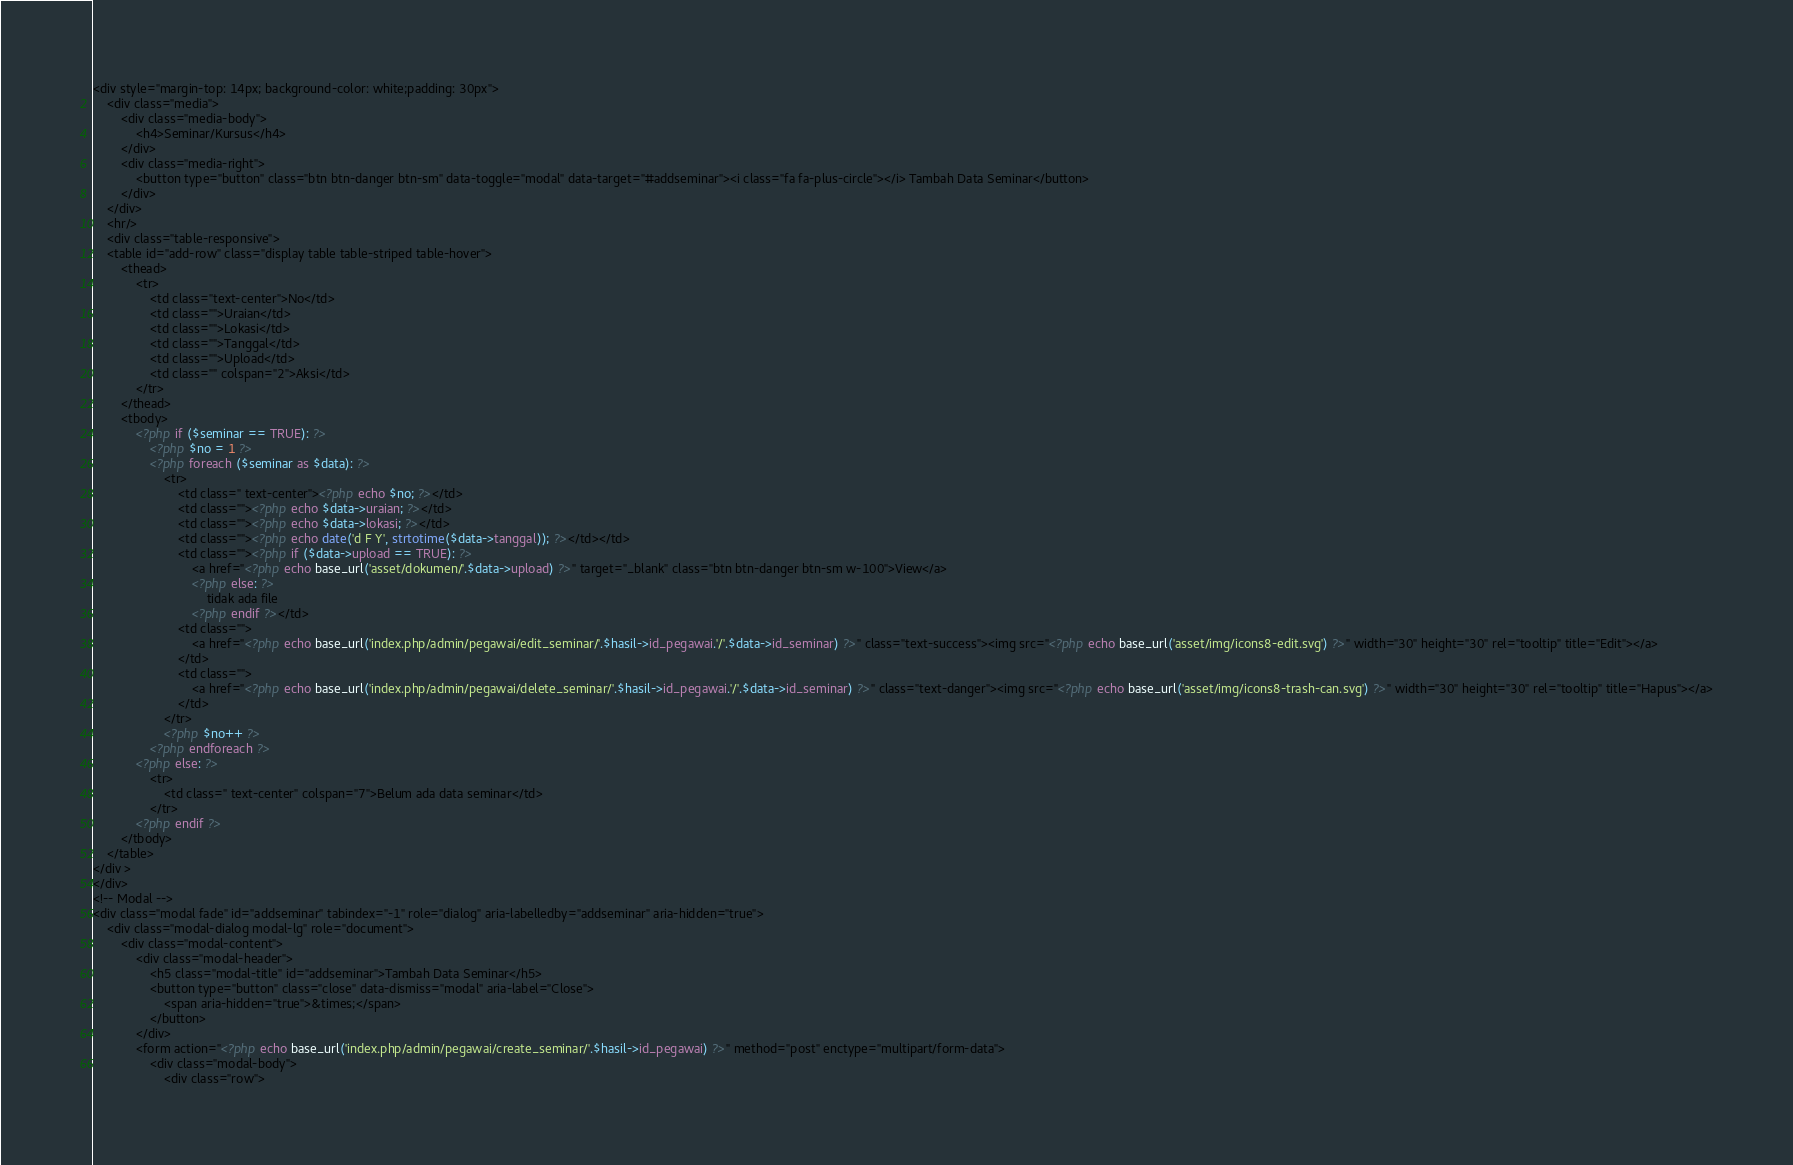<code> <loc_0><loc_0><loc_500><loc_500><_PHP_><div style="margin-top: 14px; background-color: white;padding: 30px">
	<div class="media">
		<div class="media-body">
			<h4>Seminar/Kursus</h4>
		</div>
		<div class="media-right">
			<button type="button" class="btn btn-danger btn-sm" data-toggle="modal" data-target="#addseminar"><i class="fa fa-plus-circle"></i> Tambah Data Seminar</button>
		</div>
	</div>
	<hr/>
	<div class="table-responsive">
	<table id="add-row" class="display table table-striped table-hover">
		<thead>
			<tr>
				<td class="text-center">No</td>
				<td class="">Uraian</td>
				<td class="">Lokasi</td>
				<td class="">Tanggal</td>
				<td class="">Upload</td>
				<td class="" colspan="2">Aksi</td>
			</tr>
		</thead>
		<tbody>
			<?php if ($seminar == TRUE): ?>
				<?php $no = 1 ?>
				<?php foreach ($seminar as $data): ?>
					<tr>
						<td class=" text-center"><?php echo $no; ?></td>
						<td class=""><?php echo $data->uraian; ?></td>
						<td class=""><?php echo $data->lokasi; ?></td>
						<td class=""><?php echo date('d F Y', strtotime($data->tanggal)); ?></td></td>
						<td class=""><?php if ($data->upload == TRUE): ?>
							<a href="<?php echo base_url('asset/dokumen/'.$data->upload) ?>" target="_blank" class="btn btn-danger btn-sm w-100">View</a>
							<?php else: ?>
								tidak ada file
                  			<?php endif ?></td>
						<td class="">
							<a href="<?php echo base_url('index.php/admin/pegawai/edit_seminar/'.$hasil->id_pegawai.'/'.$data->id_seminar) ?>" class="text-success"><img src="<?php echo base_url('asset/img/icons8-edit.svg') ?>" width="30" height="30" rel="tooltip" title="Edit"></a>
						</td>
						<td class="">
							<a href="<?php echo base_url('index.php/admin/pegawai/delete_seminar/'.$hasil->id_pegawai.'/'.$data->id_seminar) ?>" class="text-danger"><img src="<?php echo base_url('asset/img/icons8-trash-can.svg') ?>" width="30" height="30" rel="tooltip" title="Hapus"></a>
						</td>
					</tr>
					<?php $no++ ?>
				<?php endforeach ?>
			<?php else: ?>
				<tr>
					<td class=" text-center" colspan="7">Belum ada data seminar</td>
				</tr>
			<?php endif ?>
		</tbody>
	</table>
</div >
</div>
<!-- Modal -->
<div class="modal fade" id="addseminar" tabindex="-1" role="dialog" aria-labelledby="addseminar" aria-hidden="true">
	<div class="modal-dialog modal-lg" role="document">
		<div class="modal-content">
			<div class="modal-header">
				<h5 class="modal-title" id="addseminar">Tambah Data Seminar</h5>
				<button type="button" class="close" data-dismiss="modal" aria-label="Close">
					<span aria-hidden="true">&times;</span>
				</button>
			</div>
			<form action="<?php echo base_url('index.php/admin/pegawai/create_seminar/'.$hasil->id_pegawai) ?>" method="post" enctype="multipart/form-data">
				<div class="modal-body">
					<div class="row"></code> 